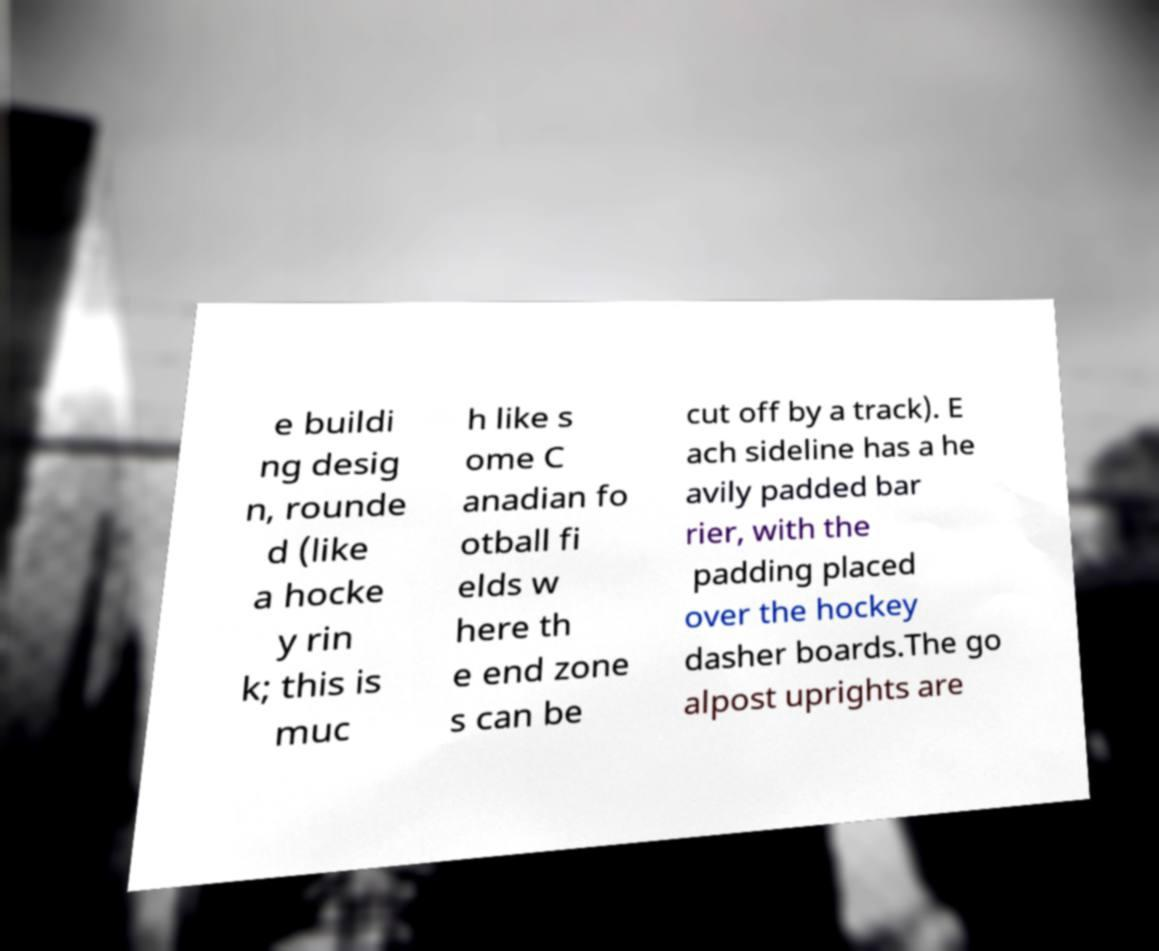Could you assist in decoding the text presented in this image and type it out clearly? e buildi ng desig n, rounde d (like a hocke y rin k; this is muc h like s ome C anadian fo otball fi elds w here th e end zone s can be cut off by a track). E ach sideline has a he avily padded bar rier, with the padding placed over the hockey dasher boards.The go alpost uprights are 